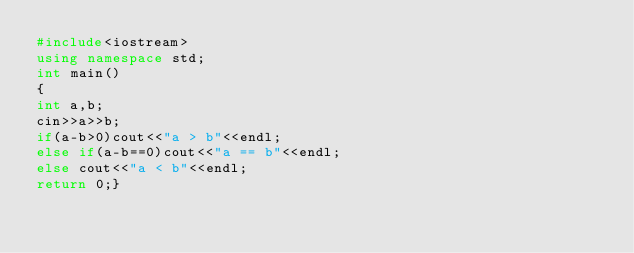Convert code to text. <code><loc_0><loc_0><loc_500><loc_500><_C++_>#include<iostream>
using namespace std;
int main()
{
int a,b;
cin>>a>>b;
if(a-b>0)cout<<"a > b"<<endl;
else if(a-b==0)cout<<"a == b"<<endl;
else cout<<"a < b"<<endl;
return 0;}
</code> 